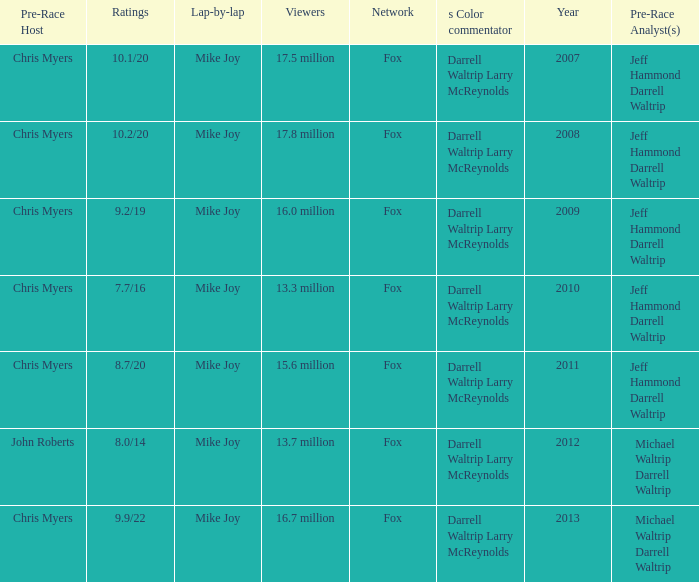Which Network has 16.0 million Viewers? Fox. 